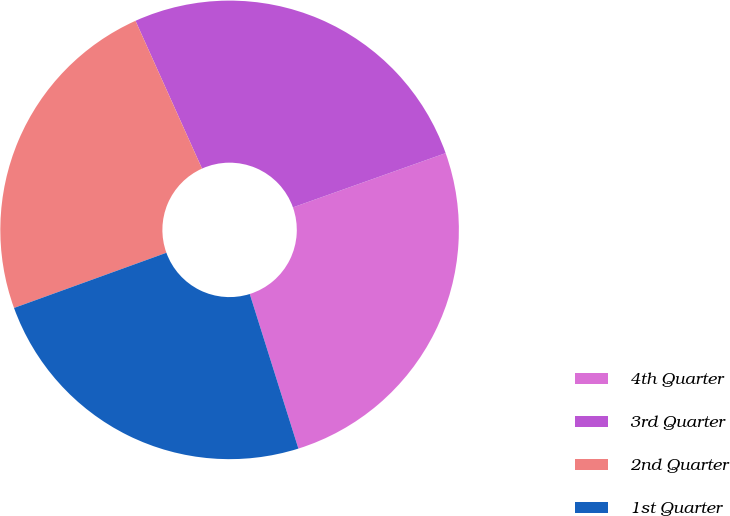Convert chart. <chart><loc_0><loc_0><loc_500><loc_500><pie_chart><fcel>4th Quarter<fcel>3rd Quarter<fcel>2nd Quarter<fcel>1st Quarter<nl><fcel>25.58%<fcel>26.3%<fcel>23.8%<fcel>24.32%<nl></chart> 